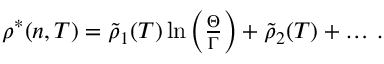<formula> <loc_0><loc_0><loc_500><loc_500>\begin{array} { r } { \rho ^ { * } ( n , T ) = \tilde { \rho } _ { 1 } ( T ) \ln \left ( \frac { \Theta } { \Gamma } \right ) + \tilde { \rho } _ { 2 } ( T ) + \dots \, . } \end{array}</formula> 